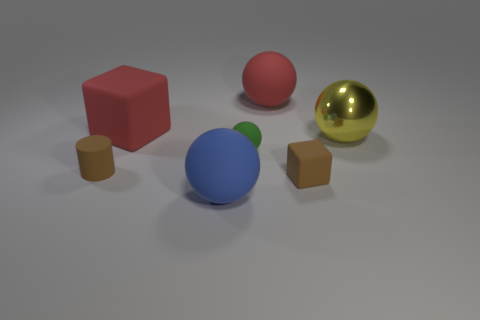Subtract all blue balls. How many balls are left? 3 Subtract all blue balls. How many balls are left? 3 Add 1 large green matte things. How many objects exist? 8 Subtract all purple spheres. Subtract all cyan cylinders. How many spheres are left? 4 Subtract all cylinders. How many objects are left? 6 Subtract all brown rubber blocks. Subtract all small cylinders. How many objects are left? 5 Add 4 large red rubber things. How many large red rubber things are left? 6 Add 7 large brown metallic objects. How many large brown metallic objects exist? 7 Subtract 1 brown cubes. How many objects are left? 6 